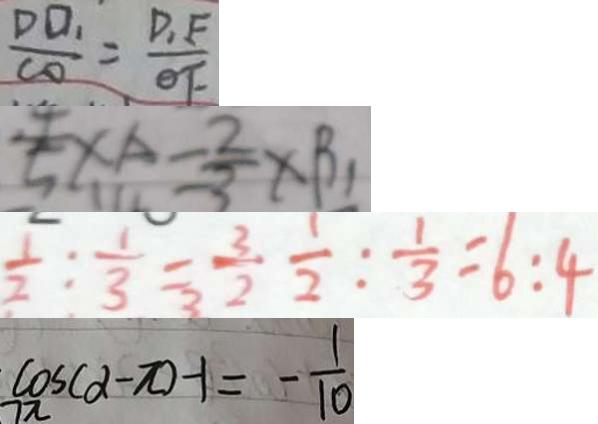Convert formula to latex. <formula><loc_0><loc_0><loc_500><loc_500>\frac { D O _ { 1 } } { C O } = \frac { D _ { 1 } F } { \theta F } 
 \frac { 4 } { 5 } \times A = \frac { 2 } { 3 } \times B _ { 1 } 
 \frac { 1 } { 2 } : \frac { 1 } { 3 } = \frac { 3 } { 2 } \frac { 1 } { 2 } : \frac { 1 } { 3 } = 6 : 4 
 \cos ( \alpha - \pi ) - 1 = - \frac { 1 } { 1 0 }</formula> 